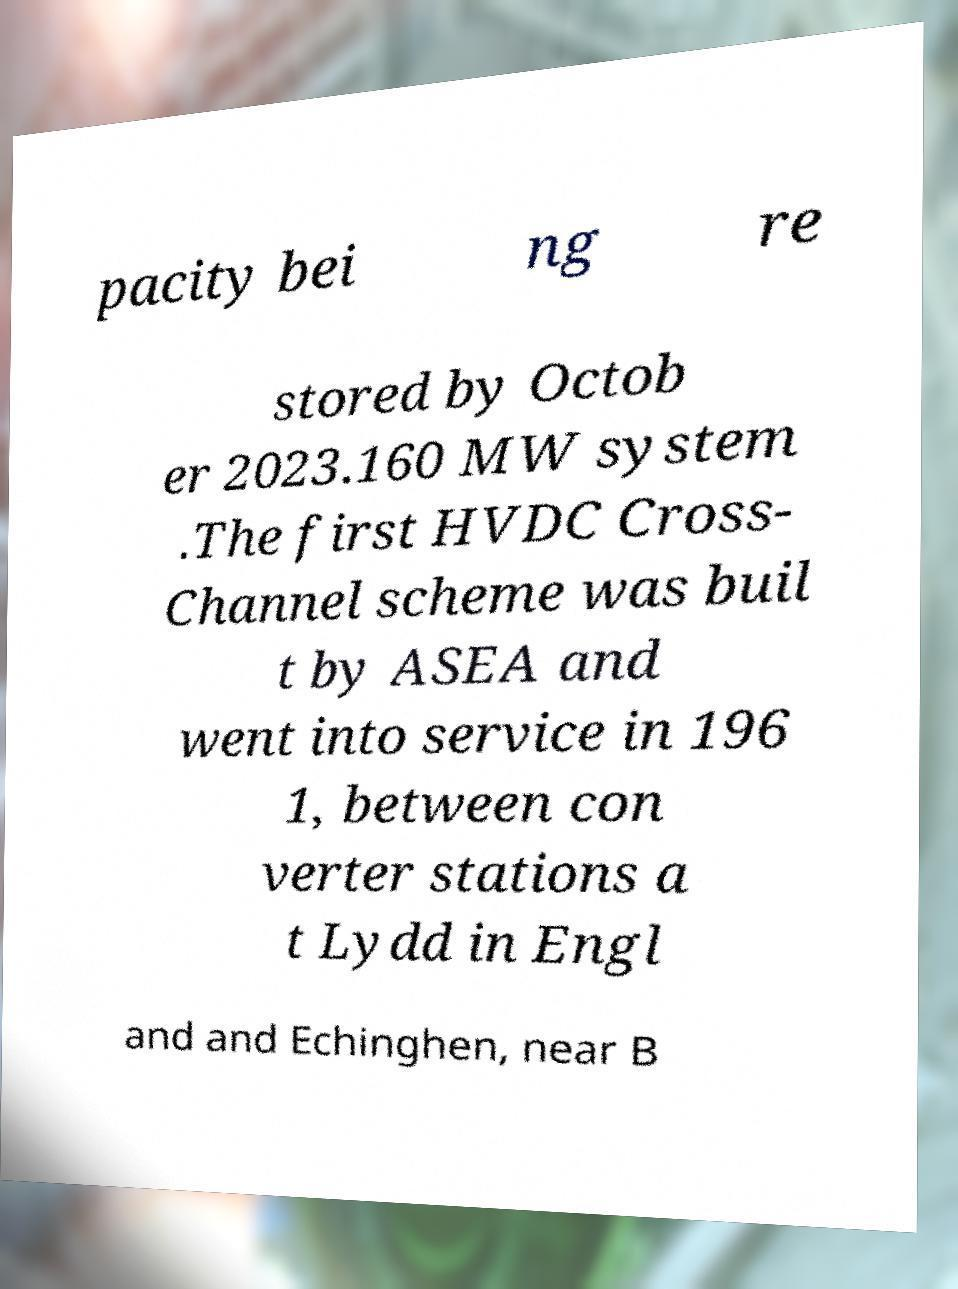Could you extract and type out the text from this image? pacity bei ng re stored by Octob er 2023.160 MW system .The first HVDC Cross- Channel scheme was buil t by ASEA and went into service in 196 1, between con verter stations a t Lydd in Engl and and Echinghen, near B 